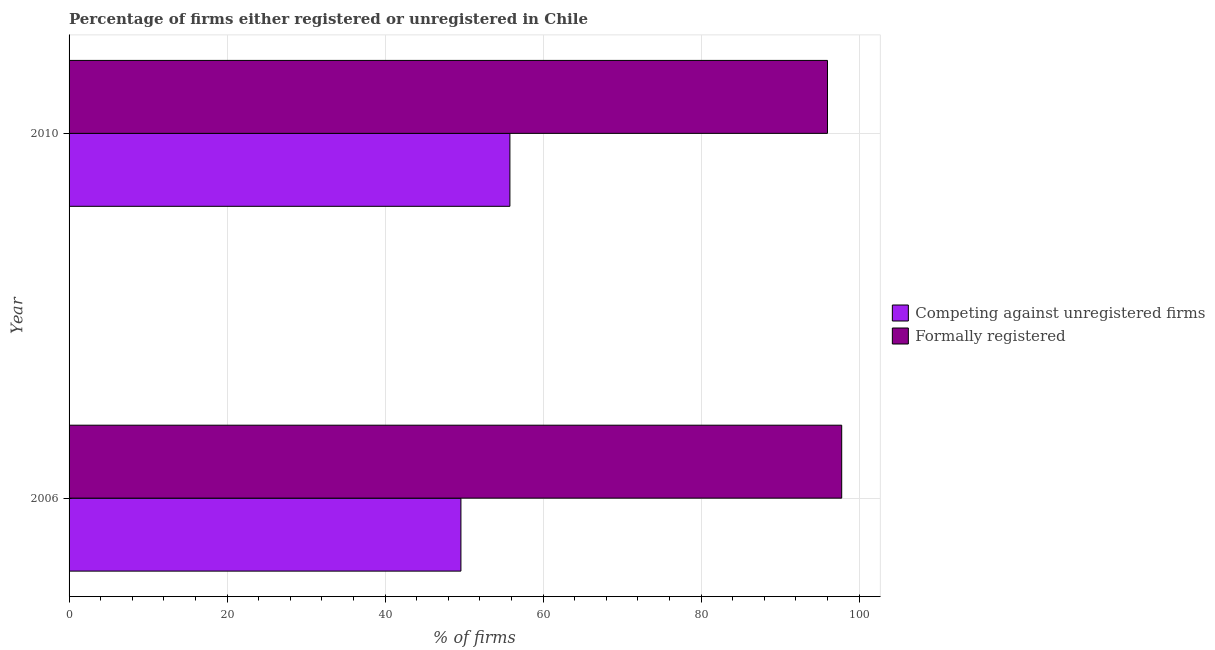Are the number of bars on each tick of the Y-axis equal?
Give a very brief answer. Yes. How many bars are there on the 2nd tick from the bottom?
Provide a succinct answer. 2. What is the label of the 2nd group of bars from the top?
Make the answer very short. 2006. What is the percentage of registered firms in 2006?
Your response must be concise. 49.6. Across all years, what is the maximum percentage of formally registered firms?
Your answer should be compact. 97.8. Across all years, what is the minimum percentage of formally registered firms?
Ensure brevity in your answer.  96. What is the total percentage of registered firms in the graph?
Provide a short and direct response. 105.4. What is the difference between the percentage of formally registered firms in 2006 and that in 2010?
Your answer should be compact. 1.8. What is the difference between the percentage of formally registered firms in 2010 and the percentage of registered firms in 2006?
Offer a very short reply. 46.4. What is the average percentage of registered firms per year?
Offer a very short reply. 52.7. In the year 2010, what is the difference between the percentage of formally registered firms and percentage of registered firms?
Your answer should be compact. 40.2. In how many years, is the percentage of registered firms greater than 56 %?
Your answer should be compact. 0. What is the ratio of the percentage of formally registered firms in 2006 to that in 2010?
Your response must be concise. 1.02. What does the 2nd bar from the top in 2010 represents?
Provide a short and direct response. Competing against unregistered firms. What does the 2nd bar from the bottom in 2006 represents?
Offer a terse response. Formally registered. How many bars are there?
Provide a short and direct response. 4. What is the difference between two consecutive major ticks on the X-axis?
Provide a short and direct response. 20. Are the values on the major ticks of X-axis written in scientific E-notation?
Keep it short and to the point. No. Does the graph contain any zero values?
Offer a terse response. No. Does the graph contain grids?
Your response must be concise. Yes. Where does the legend appear in the graph?
Ensure brevity in your answer.  Center right. How are the legend labels stacked?
Your answer should be very brief. Vertical. What is the title of the graph?
Your answer should be very brief. Percentage of firms either registered or unregistered in Chile. What is the label or title of the X-axis?
Give a very brief answer. % of firms. What is the label or title of the Y-axis?
Give a very brief answer. Year. What is the % of firms of Competing against unregistered firms in 2006?
Offer a very short reply. 49.6. What is the % of firms of Formally registered in 2006?
Your response must be concise. 97.8. What is the % of firms of Competing against unregistered firms in 2010?
Offer a very short reply. 55.8. What is the % of firms of Formally registered in 2010?
Your answer should be very brief. 96. Across all years, what is the maximum % of firms in Competing against unregistered firms?
Give a very brief answer. 55.8. Across all years, what is the maximum % of firms of Formally registered?
Give a very brief answer. 97.8. Across all years, what is the minimum % of firms of Competing against unregistered firms?
Provide a succinct answer. 49.6. Across all years, what is the minimum % of firms in Formally registered?
Make the answer very short. 96. What is the total % of firms of Competing against unregistered firms in the graph?
Make the answer very short. 105.4. What is the total % of firms in Formally registered in the graph?
Provide a short and direct response. 193.8. What is the difference between the % of firms of Competing against unregistered firms in 2006 and that in 2010?
Offer a terse response. -6.2. What is the difference between the % of firms in Formally registered in 2006 and that in 2010?
Your answer should be very brief. 1.8. What is the difference between the % of firms in Competing against unregistered firms in 2006 and the % of firms in Formally registered in 2010?
Offer a very short reply. -46.4. What is the average % of firms of Competing against unregistered firms per year?
Provide a succinct answer. 52.7. What is the average % of firms of Formally registered per year?
Ensure brevity in your answer.  96.9. In the year 2006, what is the difference between the % of firms in Competing against unregistered firms and % of firms in Formally registered?
Your answer should be very brief. -48.2. In the year 2010, what is the difference between the % of firms of Competing against unregistered firms and % of firms of Formally registered?
Provide a succinct answer. -40.2. What is the ratio of the % of firms in Formally registered in 2006 to that in 2010?
Your answer should be compact. 1.02. What is the difference between the highest and the lowest % of firms in Competing against unregistered firms?
Make the answer very short. 6.2. What is the difference between the highest and the lowest % of firms of Formally registered?
Your answer should be very brief. 1.8. 